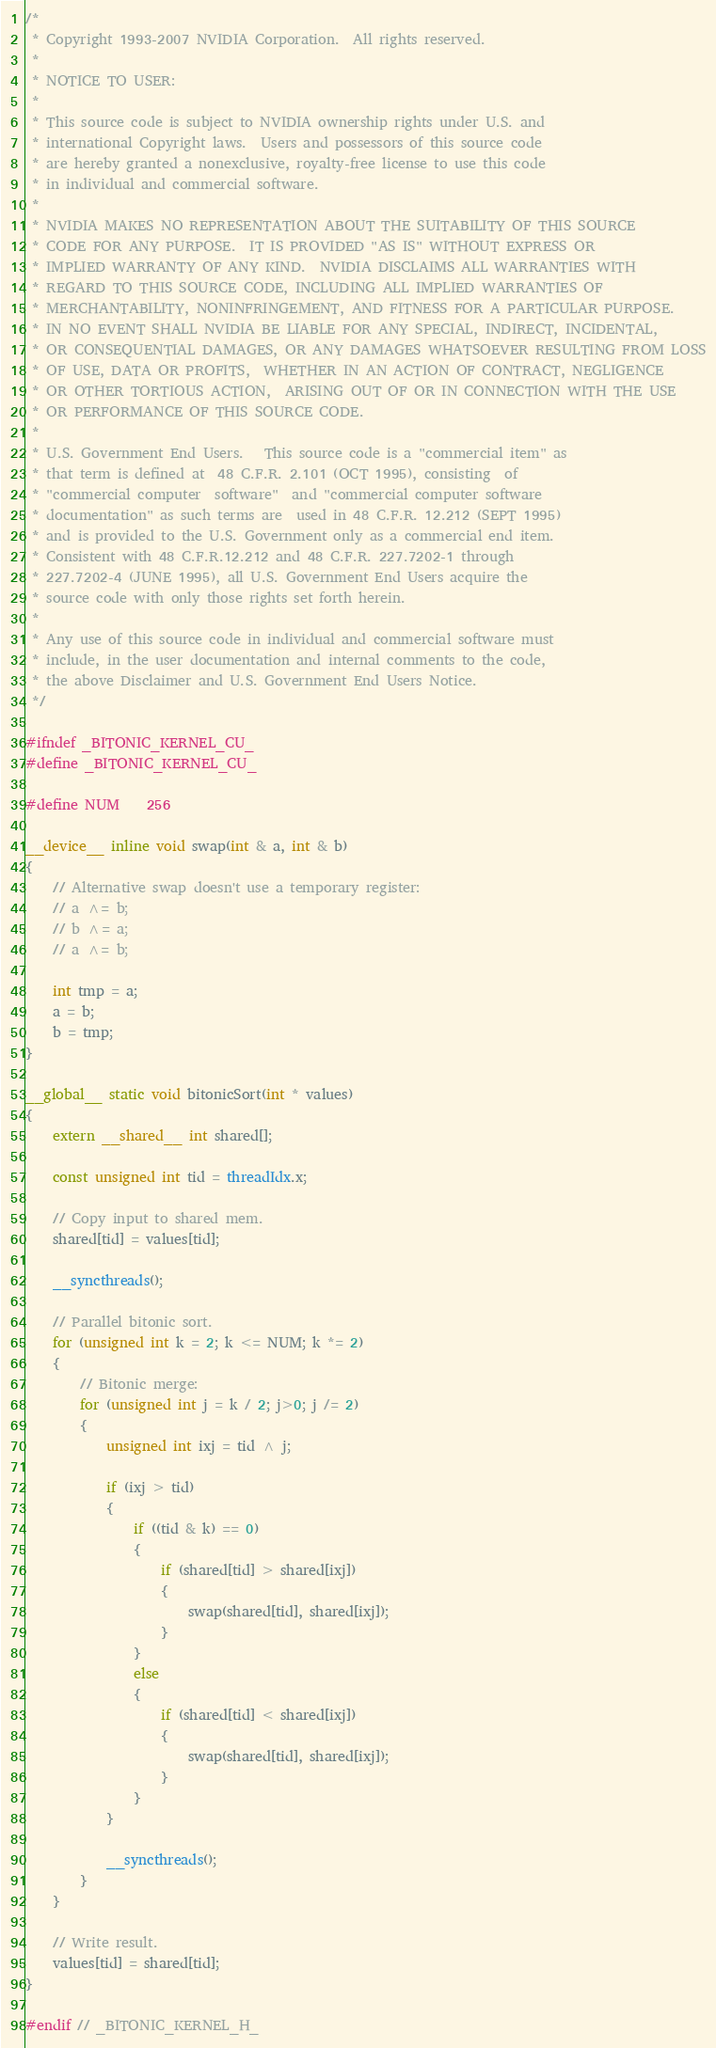Convert code to text. <code><loc_0><loc_0><loc_500><loc_500><_Cuda_>/*
 * Copyright 1993-2007 NVIDIA Corporation.  All rights reserved.
 *
 * NOTICE TO USER:
 *
 * This source code is subject to NVIDIA ownership rights under U.S. and
 * international Copyright laws.  Users and possessors of this source code
 * are hereby granted a nonexclusive, royalty-free license to use this code
 * in individual and commercial software.
 *
 * NVIDIA MAKES NO REPRESENTATION ABOUT THE SUITABILITY OF THIS SOURCE
 * CODE FOR ANY PURPOSE.  IT IS PROVIDED "AS IS" WITHOUT EXPRESS OR
 * IMPLIED WARRANTY OF ANY KIND.  NVIDIA DISCLAIMS ALL WARRANTIES WITH
 * REGARD TO THIS SOURCE CODE, INCLUDING ALL IMPLIED WARRANTIES OF
 * MERCHANTABILITY, NONINFRINGEMENT, AND FITNESS FOR A PARTICULAR PURPOSE.
 * IN NO EVENT SHALL NVIDIA BE LIABLE FOR ANY SPECIAL, INDIRECT, INCIDENTAL,
 * OR CONSEQUENTIAL DAMAGES, OR ANY DAMAGES WHATSOEVER RESULTING FROM LOSS
 * OF USE, DATA OR PROFITS,  WHETHER IN AN ACTION OF CONTRACT, NEGLIGENCE
 * OR OTHER TORTIOUS ACTION,  ARISING OUT OF OR IN CONNECTION WITH THE USE
 * OR PERFORMANCE OF THIS SOURCE CODE.
 *
 * U.S. Government End Users.   This source code is a "commercial item" as
 * that term is defined at  48 C.F.R. 2.101 (OCT 1995), consisting  of
 * "commercial computer  software"  and "commercial computer software
 * documentation" as such terms are  used in 48 C.F.R. 12.212 (SEPT 1995)
 * and is provided to the U.S. Government only as a commercial end item.
 * Consistent with 48 C.F.R.12.212 and 48 C.F.R. 227.7202-1 through
 * 227.7202-4 (JUNE 1995), all U.S. Government End Users acquire the
 * source code with only those rights set forth herein.
 *
 * Any use of this source code in individual and commercial software must
 * include, in the user documentation and internal comments to the code,
 * the above Disclaimer and U.S. Government End Users Notice.
 */

#ifndef _BITONIC_KERNEL_CU_
#define _BITONIC_KERNEL_CU_

#define NUM    256

__device__ inline void swap(int & a, int & b)
{
	// Alternative swap doesn't use a temporary register:
	// a ^= b;
	// b ^= a;
	// a ^= b;
	
    int tmp = a;
    a = b;
    b = tmp;
}

__global__ static void bitonicSort(int * values)
{
    extern __shared__ int shared[];

    const unsigned int tid = threadIdx.x;

    // Copy input to shared mem.
    shared[tid] = values[tid];

    __syncthreads();

    // Parallel bitonic sort.
    for (unsigned int k = 2; k <= NUM; k *= 2)
    {
        // Bitonic merge:
        for (unsigned int j = k / 2; j>0; j /= 2)
        {
            unsigned int ixj = tid ^ j;
            
            if (ixj > tid)
            {
                if ((tid & k) == 0)
                {
                    if (shared[tid] > shared[ixj])
                    {
                        swap(shared[tid], shared[ixj]);
                    }
                }
                else
                {
                    if (shared[tid] < shared[ixj])
                    {
                        swap(shared[tid], shared[ixj]);
                    }
                }
            }
            
            __syncthreads();
        }
    }

    // Write result.
    values[tid] = shared[tid];
}

#endif // _BITONIC_KERNEL_H_
</code> 